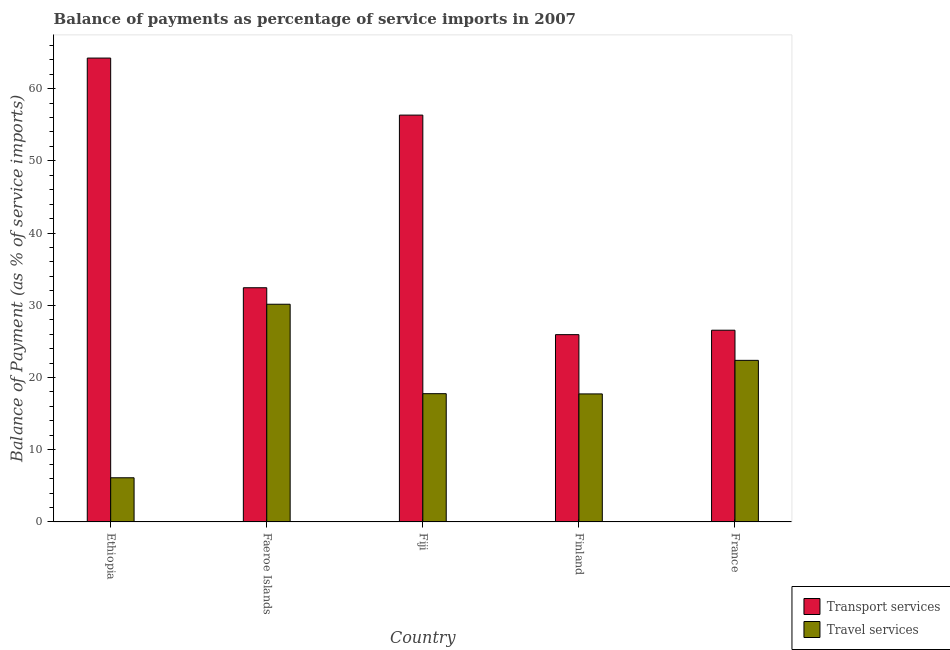How many groups of bars are there?
Make the answer very short. 5. Are the number of bars per tick equal to the number of legend labels?
Give a very brief answer. Yes. Are the number of bars on each tick of the X-axis equal?
Give a very brief answer. Yes. How many bars are there on the 1st tick from the right?
Provide a succinct answer. 2. What is the balance of payments of travel services in France?
Your answer should be very brief. 22.37. Across all countries, what is the maximum balance of payments of transport services?
Your answer should be very brief. 64.23. Across all countries, what is the minimum balance of payments of travel services?
Provide a short and direct response. 6.11. In which country was the balance of payments of travel services maximum?
Offer a very short reply. Faeroe Islands. In which country was the balance of payments of travel services minimum?
Your answer should be very brief. Ethiopia. What is the total balance of payments of transport services in the graph?
Provide a short and direct response. 205.47. What is the difference between the balance of payments of transport services in Ethiopia and that in France?
Your response must be concise. 37.68. What is the difference between the balance of payments of travel services in Faeroe Islands and the balance of payments of transport services in Finland?
Your answer should be very brief. 4.21. What is the average balance of payments of travel services per country?
Provide a succinct answer. 18.82. What is the difference between the balance of payments of transport services and balance of payments of travel services in Fiji?
Offer a terse response. 38.57. In how many countries, is the balance of payments of travel services greater than 24 %?
Offer a terse response. 1. What is the ratio of the balance of payments of travel services in Fiji to that in Finland?
Keep it short and to the point. 1. Is the balance of payments of transport services in Ethiopia less than that in France?
Ensure brevity in your answer.  No. Is the difference between the balance of payments of travel services in Faeroe Islands and Fiji greater than the difference between the balance of payments of transport services in Faeroe Islands and Fiji?
Keep it short and to the point. Yes. What is the difference between the highest and the second highest balance of payments of travel services?
Your answer should be compact. 7.77. What is the difference between the highest and the lowest balance of payments of transport services?
Provide a succinct answer. 38.3. Is the sum of the balance of payments of travel services in Fiji and Finland greater than the maximum balance of payments of transport services across all countries?
Your answer should be compact. No. What does the 1st bar from the left in France represents?
Provide a succinct answer. Transport services. What does the 1st bar from the right in Finland represents?
Provide a succinct answer. Travel services. How many bars are there?
Offer a terse response. 10. Are all the bars in the graph horizontal?
Provide a succinct answer. No. How many countries are there in the graph?
Your response must be concise. 5. Does the graph contain any zero values?
Make the answer very short. No. Does the graph contain grids?
Your answer should be very brief. No. How many legend labels are there?
Provide a short and direct response. 2. What is the title of the graph?
Keep it short and to the point. Balance of payments as percentage of service imports in 2007. Does "GDP at market prices" appear as one of the legend labels in the graph?
Your answer should be very brief. No. What is the label or title of the Y-axis?
Give a very brief answer. Balance of Payment (as % of service imports). What is the Balance of Payment (as % of service imports) in Transport services in Ethiopia?
Provide a short and direct response. 64.23. What is the Balance of Payment (as % of service imports) of Travel services in Ethiopia?
Ensure brevity in your answer.  6.11. What is the Balance of Payment (as % of service imports) of Transport services in Faeroe Islands?
Offer a terse response. 32.43. What is the Balance of Payment (as % of service imports) in Travel services in Faeroe Islands?
Ensure brevity in your answer.  30.14. What is the Balance of Payment (as % of service imports) in Transport services in Fiji?
Your response must be concise. 56.33. What is the Balance of Payment (as % of service imports) of Travel services in Fiji?
Your answer should be compact. 17.76. What is the Balance of Payment (as % of service imports) in Transport services in Finland?
Ensure brevity in your answer.  25.93. What is the Balance of Payment (as % of service imports) in Travel services in Finland?
Make the answer very short. 17.73. What is the Balance of Payment (as % of service imports) in Transport services in France?
Offer a terse response. 26.55. What is the Balance of Payment (as % of service imports) in Travel services in France?
Give a very brief answer. 22.37. Across all countries, what is the maximum Balance of Payment (as % of service imports) in Transport services?
Offer a terse response. 64.23. Across all countries, what is the maximum Balance of Payment (as % of service imports) of Travel services?
Make the answer very short. 30.14. Across all countries, what is the minimum Balance of Payment (as % of service imports) in Transport services?
Your answer should be compact. 25.93. Across all countries, what is the minimum Balance of Payment (as % of service imports) of Travel services?
Provide a short and direct response. 6.11. What is the total Balance of Payment (as % of service imports) of Transport services in the graph?
Give a very brief answer. 205.47. What is the total Balance of Payment (as % of service imports) of Travel services in the graph?
Provide a succinct answer. 94.11. What is the difference between the Balance of Payment (as % of service imports) of Transport services in Ethiopia and that in Faeroe Islands?
Your answer should be compact. 31.8. What is the difference between the Balance of Payment (as % of service imports) in Travel services in Ethiopia and that in Faeroe Islands?
Offer a terse response. -24.03. What is the difference between the Balance of Payment (as % of service imports) in Transport services in Ethiopia and that in Fiji?
Offer a very short reply. 7.9. What is the difference between the Balance of Payment (as % of service imports) in Travel services in Ethiopia and that in Fiji?
Ensure brevity in your answer.  -11.64. What is the difference between the Balance of Payment (as % of service imports) of Transport services in Ethiopia and that in Finland?
Make the answer very short. 38.3. What is the difference between the Balance of Payment (as % of service imports) of Travel services in Ethiopia and that in Finland?
Your answer should be very brief. -11.61. What is the difference between the Balance of Payment (as % of service imports) of Transport services in Ethiopia and that in France?
Provide a succinct answer. 37.68. What is the difference between the Balance of Payment (as % of service imports) of Travel services in Ethiopia and that in France?
Your response must be concise. -16.26. What is the difference between the Balance of Payment (as % of service imports) in Transport services in Faeroe Islands and that in Fiji?
Keep it short and to the point. -23.91. What is the difference between the Balance of Payment (as % of service imports) in Travel services in Faeroe Islands and that in Fiji?
Provide a short and direct response. 12.38. What is the difference between the Balance of Payment (as % of service imports) in Transport services in Faeroe Islands and that in Finland?
Your response must be concise. 6.49. What is the difference between the Balance of Payment (as % of service imports) of Travel services in Faeroe Islands and that in Finland?
Your response must be concise. 12.42. What is the difference between the Balance of Payment (as % of service imports) in Transport services in Faeroe Islands and that in France?
Offer a terse response. 5.88. What is the difference between the Balance of Payment (as % of service imports) of Travel services in Faeroe Islands and that in France?
Provide a succinct answer. 7.77. What is the difference between the Balance of Payment (as % of service imports) of Transport services in Fiji and that in Finland?
Provide a succinct answer. 30.4. What is the difference between the Balance of Payment (as % of service imports) of Travel services in Fiji and that in Finland?
Give a very brief answer. 0.03. What is the difference between the Balance of Payment (as % of service imports) in Transport services in Fiji and that in France?
Your answer should be compact. 29.79. What is the difference between the Balance of Payment (as % of service imports) of Travel services in Fiji and that in France?
Keep it short and to the point. -4.62. What is the difference between the Balance of Payment (as % of service imports) of Transport services in Finland and that in France?
Provide a succinct answer. -0.61. What is the difference between the Balance of Payment (as % of service imports) of Travel services in Finland and that in France?
Offer a terse response. -4.65. What is the difference between the Balance of Payment (as % of service imports) of Transport services in Ethiopia and the Balance of Payment (as % of service imports) of Travel services in Faeroe Islands?
Offer a terse response. 34.09. What is the difference between the Balance of Payment (as % of service imports) in Transport services in Ethiopia and the Balance of Payment (as % of service imports) in Travel services in Fiji?
Give a very brief answer. 46.47. What is the difference between the Balance of Payment (as % of service imports) in Transport services in Ethiopia and the Balance of Payment (as % of service imports) in Travel services in Finland?
Give a very brief answer. 46.5. What is the difference between the Balance of Payment (as % of service imports) in Transport services in Ethiopia and the Balance of Payment (as % of service imports) in Travel services in France?
Give a very brief answer. 41.86. What is the difference between the Balance of Payment (as % of service imports) of Transport services in Faeroe Islands and the Balance of Payment (as % of service imports) of Travel services in Fiji?
Provide a short and direct response. 14.67. What is the difference between the Balance of Payment (as % of service imports) in Transport services in Faeroe Islands and the Balance of Payment (as % of service imports) in Travel services in Finland?
Make the answer very short. 14.7. What is the difference between the Balance of Payment (as % of service imports) of Transport services in Faeroe Islands and the Balance of Payment (as % of service imports) of Travel services in France?
Your answer should be very brief. 10.05. What is the difference between the Balance of Payment (as % of service imports) of Transport services in Fiji and the Balance of Payment (as % of service imports) of Travel services in Finland?
Ensure brevity in your answer.  38.61. What is the difference between the Balance of Payment (as % of service imports) in Transport services in Fiji and the Balance of Payment (as % of service imports) in Travel services in France?
Make the answer very short. 33.96. What is the difference between the Balance of Payment (as % of service imports) in Transport services in Finland and the Balance of Payment (as % of service imports) in Travel services in France?
Make the answer very short. 3.56. What is the average Balance of Payment (as % of service imports) in Transport services per country?
Offer a very short reply. 41.09. What is the average Balance of Payment (as % of service imports) of Travel services per country?
Your response must be concise. 18.82. What is the difference between the Balance of Payment (as % of service imports) in Transport services and Balance of Payment (as % of service imports) in Travel services in Ethiopia?
Your answer should be very brief. 58.12. What is the difference between the Balance of Payment (as % of service imports) of Transport services and Balance of Payment (as % of service imports) of Travel services in Faeroe Islands?
Your answer should be compact. 2.29. What is the difference between the Balance of Payment (as % of service imports) of Transport services and Balance of Payment (as % of service imports) of Travel services in Fiji?
Keep it short and to the point. 38.57. What is the difference between the Balance of Payment (as % of service imports) of Transport services and Balance of Payment (as % of service imports) of Travel services in Finland?
Your answer should be compact. 8.21. What is the difference between the Balance of Payment (as % of service imports) in Transport services and Balance of Payment (as % of service imports) in Travel services in France?
Your response must be concise. 4.17. What is the ratio of the Balance of Payment (as % of service imports) in Transport services in Ethiopia to that in Faeroe Islands?
Give a very brief answer. 1.98. What is the ratio of the Balance of Payment (as % of service imports) in Travel services in Ethiopia to that in Faeroe Islands?
Provide a succinct answer. 0.2. What is the ratio of the Balance of Payment (as % of service imports) of Transport services in Ethiopia to that in Fiji?
Make the answer very short. 1.14. What is the ratio of the Balance of Payment (as % of service imports) of Travel services in Ethiopia to that in Fiji?
Provide a succinct answer. 0.34. What is the ratio of the Balance of Payment (as % of service imports) in Transport services in Ethiopia to that in Finland?
Give a very brief answer. 2.48. What is the ratio of the Balance of Payment (as % of service imports) in Travel services in Ethiopia to that in Finland?
Your response must be concise. 0.34. What is the ratio of the Balance of Payment (as % of service imports) in Transport services in Ethiopia to that in France?
Give a very brief answer. 2.42. What is the ratio of the Balance of Payment (as % of service imports) in Travel services in Ethiopia to that in France?
Give a very brief answer. 0.27. What is the ratio of the Balance of Payment (as % of service imports) of Transport services in Faeroe Islands to that in Fiji?
Offer a very short reply. 0.58. What is the ratio of the Balance of Payment (as % of service imports) of Travel services in Faeroe Islands to that in Fiji?
Your answer should be compact. 1.7. What is the ratio of the Balance of Payment (as % of service imports) in Transport services in Faeroe Islands to that in Finland?
Give a very brief answer. 1.25. What is the ratio of the Balance of Payment (as % of service imports) in Travel services in Faeroe Islands to that in Finland?
Your answer should be very brief. 1.7. What is the ratio of the Balance of Payment (as % of service imports) in Transport services in Faeroe Islands to that in France?
Provide a succinct answer. 1.22. What is the ratio of the Balance of Payment (as % of service imports) in Travel services in Faeroe Islands to that in France?
Provide a succinct answer. 1.35. What is the ratio of the Balance of Payment (as % of service imports) of Transport services in Fiji to that in Finland?
Your answer should be very brief. 2.17. What is the ratio of the Balance of Payment (as % of service imports) of Transport services in Fiji to that in France?
Your answer should be compact. 2.12. What is the ratio of the Balance of Payment (as % of service imports) of Travel services in Fiji to that in France?
Give a very brief answer. 0.79. What is the ratio of the Balance of Payment (as % of service imports) in Transport services in Finland to that in France?
Keep it short and to the point. 0.98. What is the ratio of the Balance of Payment (as % of service imports) in Travel services in Finland to that in France?
Keep it short and to the point. 0.79. What is the difference between the highest and the second highest Balance of Payment (as % of service imports) in Transport services?
Ensure brevity in your answer.  7.9. What is the difference between the highest and the second highest Balance of Payment (as % of service imports) in Travel services?
Ensure brevity in your answer.  7.77. What is the difference between the highest and the lowest Balance of Payment (as % of service imports) in Transport services?
Offer a very short reply. 38.3. What is the difference between the highest and the lowest Balance of Payment (as % of service imports) in Travel services?
Ensure brevity in your answer.  24.03. 